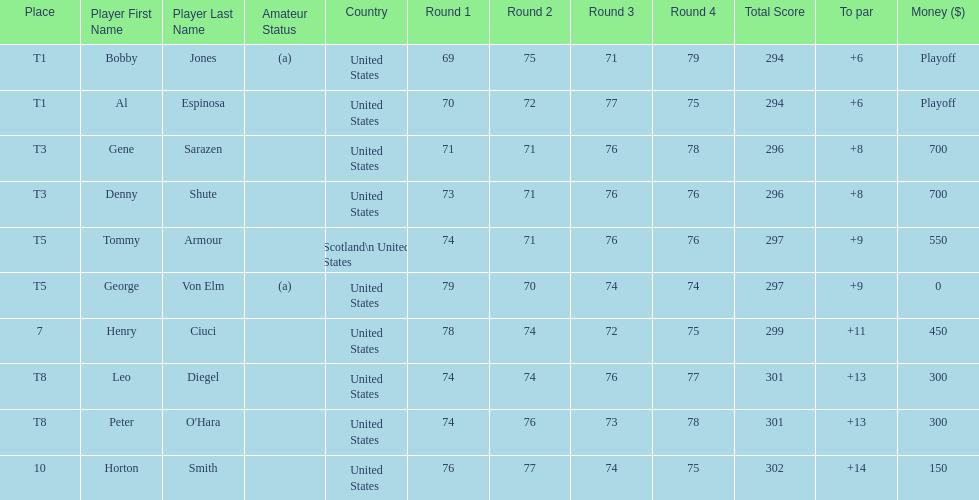Who was the last player in the top 10? Horton Smith. 